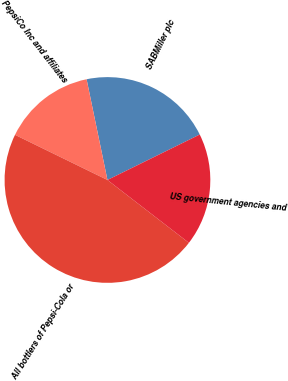<chart> <loc_0><loc_0><loc_500><loc_500><pie_chart><fcel>SABMiller plc<fcel>PepsiCo Inc and affiliates<fcel>All bottlers of Pepsi-Cola or<fcel>US government agencies and<nl><fcel>20.97%<fcel>14.52%<fcel>46.77%<fcel>17.74%<nl></chart> 